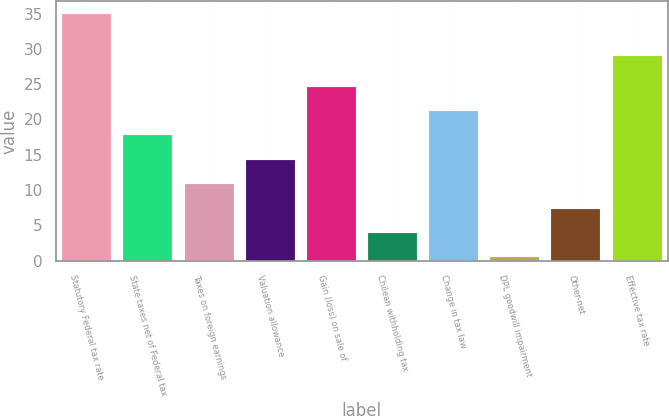<chart> <loc_0><loc_0><loc_500><loc_500><bar_chart><fcel>Statutory Federal tax rate<fcel>State taxes net of Federal tax<fcel>Taxes on foreign earnings<fcel>Valuation allowance<fcel>Gain (loss) on sale of<fcel>Chilean withholding tax<fcel>Change in tax law<fcel>DPL goodwill impairment<fcel>Other-net<fcel>Effective tax rate<nl><fcel>35<fcel>17.73<fcel>10.83<fcel>14.28<fcel>24.63<fcel>3.93<fcel>21.18<fcel>0.48<fcel>7.38<fcel>29<nl></chart> 